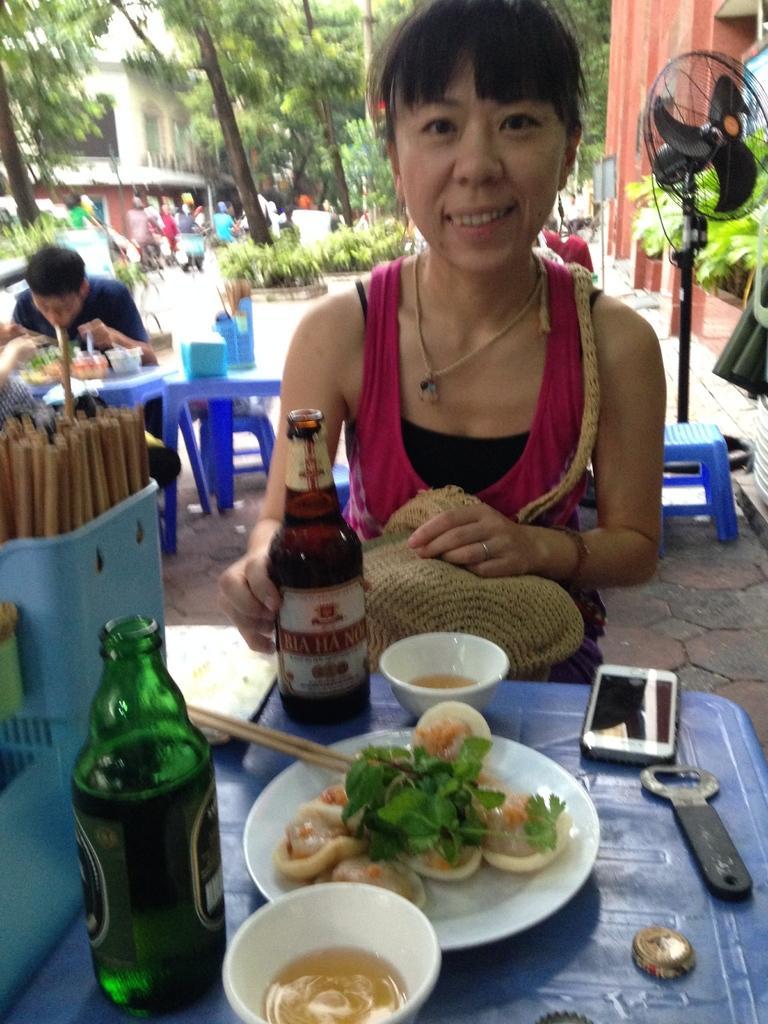How would you summarize this image in a sentence or two? In this image, we can see a woman sitting, there is a table, on that table, we can see a plate, bowls, bottles and a mobile phone. In the background, on the left side, we can see a man sitting and eating food, on the right side, we can see a fan, we can see some trees. 